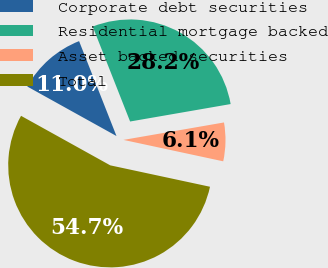Convert chart to OTSL. <chart><loc_0><loc_0><loc_500><loc_500><pie_chart><fcel>Corporate debt securities<fcel>Residential mortgage backed<fcel>Asset backed securities<fcel>Total<nl><fcel>10.96%<fcel>28.24%<fcel>6.1%<fcel>54.7%<nl></chart> 